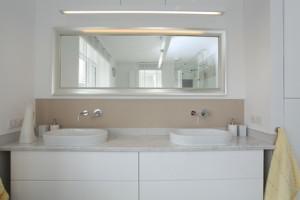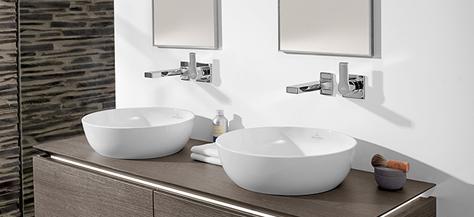The first image is the image on the left, the second image is the image on the right. Analyze the images presented: Is the assertion "In one image a sink with chrome faucet and a commode, both white, are mounted side by side on a wall." valid? Answer yes or no. No. The first image is the image on the left, the second image is the image on the right. Assess this claim about the two images: "The right image includes a tankless wall-mounted white toilet behind a similarly shaped wall-mounted white sink.". Correct or not? Answer yes or no. No. 